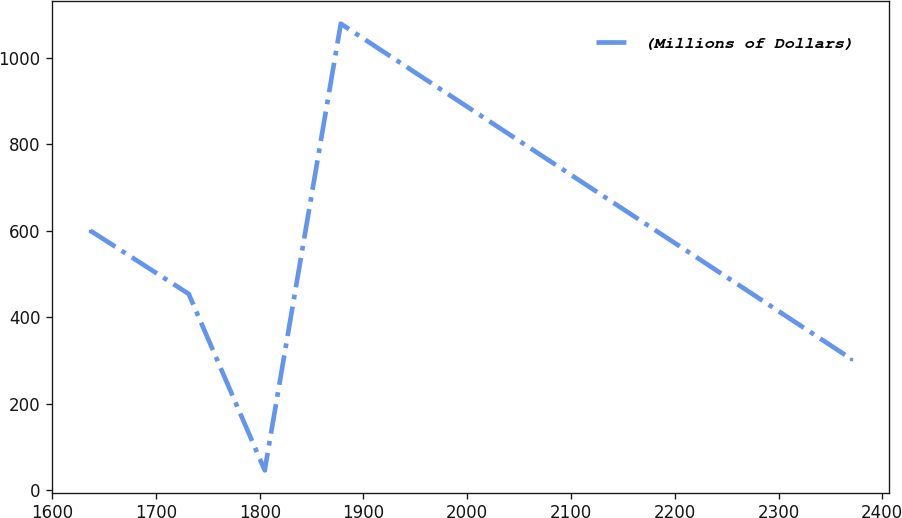Convert chart to OTSL. <chart><loc_0><loc_0><loc_500><loc_500><line_chart><ecel><fcel>(Millions of Dollars)<nl><fcel>1636.62<fcel>600.44<nl><fcel>1731.49<fcel>454.32<nl><fcel>1804.8<fcel>46.75<nl><fcel>1878.11<fcel>1078.44<nl><fcel>2369.73<fcel>304.47<nl></chart> 